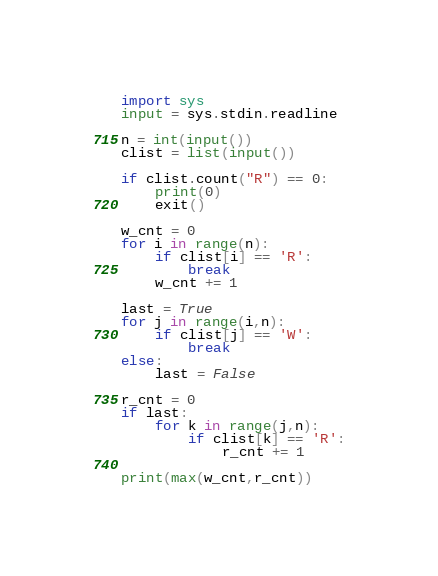<code> <loc_0><loc_0><loc_500><loc_500><_Python_>import sys
input = sys.stdin.readline

n = int(input())
clist = list(input())

if clist.count("R") == 0:
    print(0)
    exit()

w_cnt = 0
for i in range(n):
    if clist[i] == 'R':
        break
    w_cnt += 1

last = True
for j in range(i,n):
    if clist[j] == 'W':
        break
else:
    last = False

r_cnt = 0
if last:
    for k in range(j,n):
        if clist[k] == 'R':
            r_cnt += 1

print(max(w_cnt,r_cnt))


</code> 